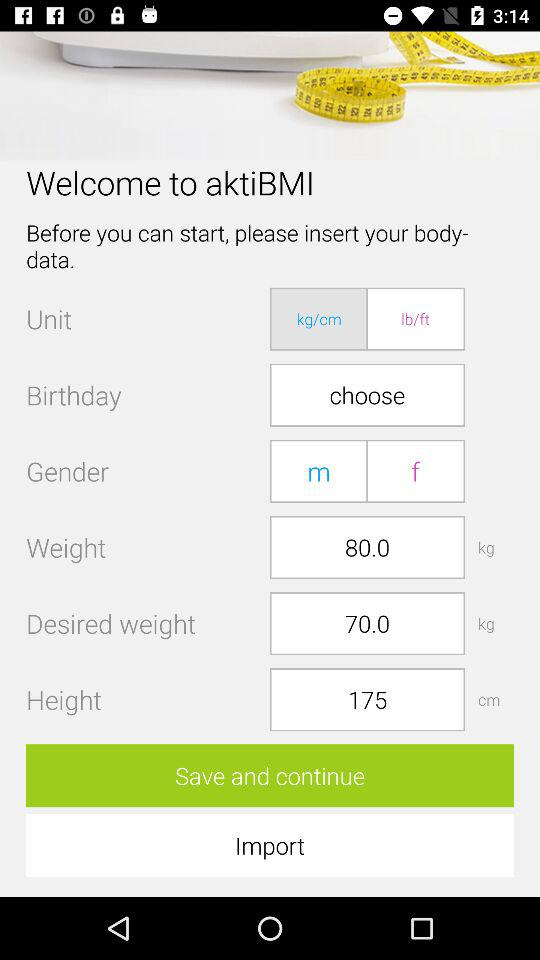How many more kg are there in the weight field than the desired weight field?
Answer the question using a single word or phrase. 10.0 